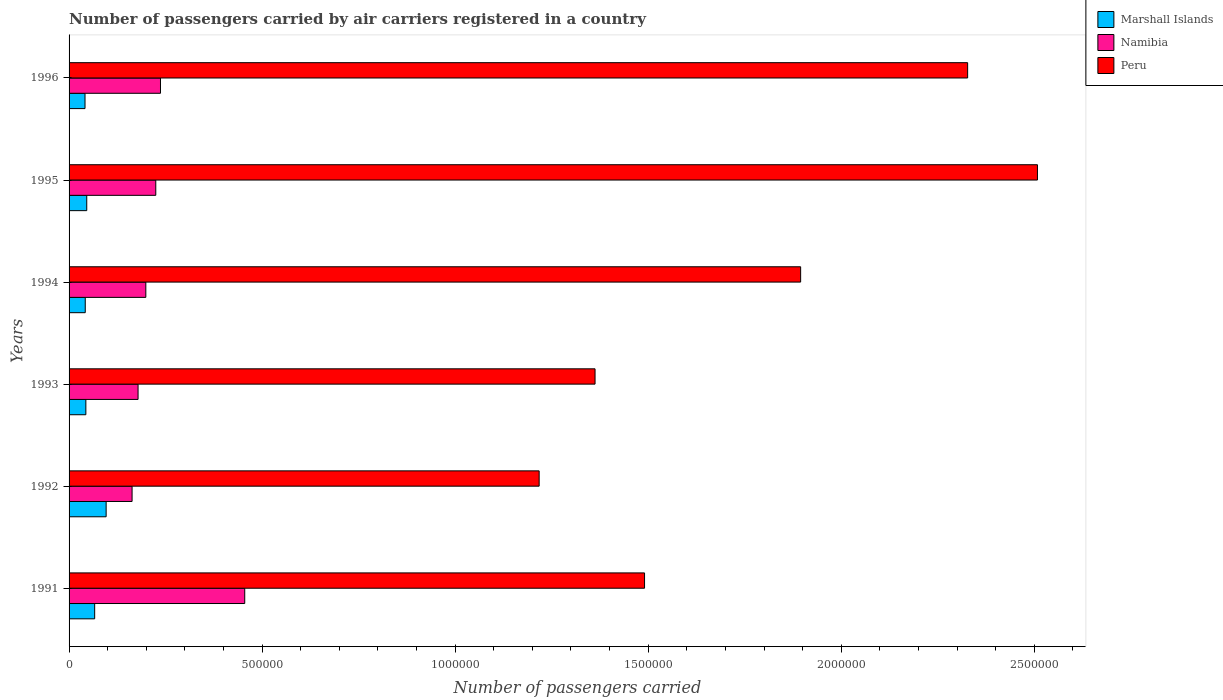How many different coloured bars are there?
Ensure brevity in your answer.  3. How many groups of bars are there?
Your answer should be compact. 6. Are the number of bars per tick equal to the number of legend labels?
Provide a succinct answer. Yes. How many bars are there on the 1st tick from the top?
Make the answer very short. 3. How many bars are there on the 2nd tick from the bottom?
Make the answer very short. 3. What is the label of the 4th group of bars from the top?
Your answer should be very brief. 1993. In how many cases, is the number of bars for a given year not equal to the number of legend labels?
Provide a short and direct response. 0. What is the number of passengers carried by air carriers in Peru in 1995?
Your answer should be compact. 2.51e+06. Across all years, what is the maximum number of passengers carried by air carriers in Marshall Islands?
Make the answer very short. 9.60e+04. Across all years, what is the minimum number of passengers carried by air carriers in Marshall Islands?
Your answer should be very brief. 4.13e+04. In which year was the number of passengers carried by air carriers in Peru maximum?
Provide a succinct answer. 1995. What is the total number of passengers carried by air carriers in Namibia in the graph?
Offer a terse response. 1.46e+06. What is the difference between the number of passengers carried by air carriers in Marshall Islands in 1991 and that in 1996?
Provide a succinct answer. 2.50e+04. What is the difference between the number of passengers carried by air carriers in Marshall Islands in 1993 and the number of passengers carried by air carriers in Namibia in 1996?
Your answer should be compact. -1.93e+05. What is the average number of passengers carried by air carriers in Namibia per year?
Your response must be concise. 2.43e+05. In the year 1991, what is the difference between the number of passengers carried by air carriers in Namibia and number of passengers carried by air carriers in Peru?
Offer a very short reply. -1.04e+06. In how many years, is the number of passengers carried by air carriers in Namibia greater than 2000000 ?
Ensure brevity in your answer.  0. What is the ratio of the number of passengers carried by air carriers in Peru in 1992 to that in 1995?
Provide a short and direct response. 0.49. Is the number of passengers carried by air carriers in Marshall Islands in 1992 less than that in 1996?
Offer a terse response. No. What is the difference between the highest and the second highest number of passengers carried by air carriers in Peru?
Your response must be concise. 1.81e+05. What is the difference between the highest and the lowest number of passengers carried by air carriers in Marshall Islands?
Offer a terse response. 5.47e+04. Is the sum of the number of passengers carried by air carriers in Marshall Islands in 1992 and 1996 greater than the maximum number of passengers carried by air carriers in Namibia across all years?
Give a very brief answer. No. What does the 2nd bar from the top in 1992 represents?
Keep it short and to the point. Namibia. What does the 1st bar from the bottom in 1996 represents?
Offer a very short reply. Marshall Islands. What is the difference between two consecutive major ticks on the X-axis?
Keep it short and to the point. 5.00e+05. Does the graph contain any zero values?
Make the answer very short. No. How many legend labels are there?
Give a very brief answer. 3. How are the legend labels stacked?
Offer a terse response. Vertical. What is the title of the graph?
Your answer should be very brief. Number of passengers carried by air carriers registered in a country. Does "United Arab Emirates" appear as one of the legend labels in the graph?
Give a very brief answer. No. What is the label or title of the X-axis?
Ensure brevity in your answer.  Number of passengers carried. What is the Number of passengers carried of Marshall Islands in 1991?
Your response must be concise. 6.63e+04. What is the Number of passengers carried of Namibia in 1991?
Your answer should be very brief. 4.55e+05. What is the Number of passengers carried in Peru in 1991?
Offer a very short reply. 1.49e+06. What is the Number of passengers carried of Marshall Islands in 1992?
Your answer should be very brief. 9.60e+04. What is the Number of passengers carried of Namibia in 1992?
Your response must be concise. 1.63e+05. What is the Number of passengers carried of Peru in 1992?
Keep it short and to the point. 1.22e+06. What is the Number of passengers carried of Marshall Islands in 1993?
Your response must be concise. 4.35e+04. What is the Number of passengers carried in Namibia in 1993?
Ensure brevity in your answer.  1.79e+05. What is the Number of passengers carried in Peru in 1993?
Your answer should be compact. 1.36e+06. What is the Number of passengers carried of Marshall Islands in 1994?
Provide a succinct answer. 4.19e+04. What is the Number of passengers carried of Namibia in 1994?
Provide a short and direct response. 1.99e+05. What is the Number of passengers carried of Peru in 1994?
Your answer should be very brief. 1.89e+06. What is the Number of passengers carried of Marshall Islands in 1995?
Your response must be concise. 4.58e+04. What is the Number of passengers carried in Namibia in 1995?
Keep it short and to the point. 2.25e+05. What is the Number of passengers carried of Peru in 1995?
Offer a terse response. 2.51e+06. What is the Number of passengers carried of Marshall Islands in 1996?
Make the answer very short. 4.13e+04. What is the Number of passengers carried of Namibia in 1996?
Offer a terse response. 2.37e+05. What is the Number of passengers carried in Peru in 1996?
Your response must be concise. 2.33e+06. Across all years, what is the maximum Number of passengers carried in Marshall Islands?
Offer a very short reply. 9.60e+04. Across all years, what is the maximum Number of passengers carried of Namibia?
Your answer should be compact. 4.55e+05. Across all years, what is the maximum Number of passengers carried in Peru?
Your answer should be very brief. 2.51e+06. Across all years, what is the minimum Number of passengers carried of Marshall Islands?
Make the answer very short. 4.13e+04. Across all years, what is the minimum Number of passengers carried in Namibia?
Offer a terse response. 1.63e+05. Across all years, what is the minimum Number of passengers carried of Peru?
Make the answer very short. 1.22e+06. What is the total Number of passengers carried in Marshall Islands in the graph?
Your answer should be compact. 3.35e+05. What is the total Number of passengers carried in Namibia in the graph?
Your answer should be compact. 1.46e+06. What is the total Number of passengers carried in Peru in the graph?
Your response must be concise. 1.08e+07. What is the difference between the Number of passengers carried in Marshall Islands in 1991 and that in 1992?
Make the answer very short. -2.97e+04. What is the difference between the Number of passengers carried of Namibia in 1991 and that in 1992?
Provide a succinct answer. 2.92e+05. What is the difference between the Number of passengers carried of Peru in 1991 and that in 1992?
Offer a very short reply. 2.73e+05. What is the difference between the Number of passengers carried in Marshall Islands in 1991 and that in 1993?
Provide a succinct answer. 2.28e+04. What is the difference between the Number of passengers carried in Namibia in 1991 and that in 1993?
Give a very brief answer. 2.76e+05. What is the difference between the Number of passengers carried of Peru in 1991 and that in 1993?
Provide a short and direct response. 1.28e+05. What is the difference between the Number of passengers carried of Marshall Islands in 1991 and that in 1994?
Offer a very short reply. 2.44e+04. What is the difference between the Number of passengers carried in Namibia in 1991 and that in 1994?
Your answer should be very brief. 2.56e+05. What is the difference between the Number of passengers carried in Peru in 1991 and that in 1994?
Provide a succinct answer. -4.04e+05. What is the difference between the Number of passengers carried of Marshall Islands in 1991 and that in 1995?
Provide a short and direct response. 2.05e+04. What is the difference between the Number of passengers carried of Namibia in 1991 and that in 1995?
Keep it short and to the point. 2.30e+05. What is the difference between the Number of passengers carried of Peru in 1991 and that in 1995?
Provide a succinct answer. -1.02e+06. What is the difference between the Number of passengers carried in Marshall Islands in 1991 and that in 1996?
Offer a very short reply. 2.50e+04. What is the difference between the Number of passengers carried of Namibia in 1991 and that in 1996?
Keep it short and to the point. 2.18e+05. What is the difference between the Number of passengers carried of Peru in 1991 and that in 1996?
Make the answer very short. -8.37e+05. What is the difference between the Number of passengers carried in Marshall Islands in 1992 and that in 1993?
Offer a terse response. 5.25e+04. What is the difference between the Number of passengers carried in Namibia in 1992 and that in 1993?
Offer a very short reply. -1.55e+04. What is the difference between the Number of passengers carried of Peru in 1992 and that in 1993?
Make the answer very short. -1.45e+05. What is the difference between the Number of passengers carried in Marshall Islands in 1992 and that in 1994?
Your answer should be very brief. 5.41e+04. What is the difference between the Number of passengers carried of Namibia in 1992 and that in 1994?
Keep it short and to the point. -3.56e+04. What is the difference between the Number of passengers carried in Peru in 1992 and that in 1994?
Offer a very short reply. -6.77e+05. What is the difference between the Number of passengers carried of Marshall Islands in 1992 and that in 1995?
Provide a short and direct response. 5.02e+04. What is the difference between the Number of passengers carried of Namibia in 1992 and that in 1995?
Keep it short and to the point. -6.14e+04. What is the difference between the Number of passengers carried of Peru in 1992 and that in 1995?
Offer a very short reply. -1.29e+06. What is the difference between the Number of passengers carried of Marshall Islands in 1992 and that in 1996?
Ensure brevity in your answer.  5.47e+04. What is the difference between the Number of passengers carried in Namibia in 1992 and that in 1996?
Give a very brief answer. -7.36e+04. What is the difference between the Number of passengers carried in Peru in 1992 and that in 1996?
Provide a succinct answer. -1.11e+06. What is the difference between the Number of passengers carried in Marshall Islands in 1993 and that in 1994?
Provide a succinct answer. 1600. What is the difference between the Number of passengers carried of Namibia in 1993 and that in 1994?
Provide a succinct answer. -2.01e+04. What is the difference between the Number of passengers carried of Peru in 1993 and that in 1994?
Your answer should be compact. -5.32e+05. What is the difference between the Number of passengers carried of Marshall Islands in 1993 and that in 1995?
Your answer should be very brief. -2300. What is the difference between the Number of passengers carried of Namibia in 1993 and that in 1995?
Provide a short and direct response. -4.59e+04. What is the difference between the Number of passengers carried in Peru in 1993 and that in 1995?
Your response must be concise. -1.15e+06. What is the difference between the Number of passengers carried of Marshall Islands in 1993 and that in 1996?
Keep it short and to the point. 2200. What is the difference between the Number of passengers carried of Namibia in 1993 and that in 1996?
Your answer should be compact. -5.81e+04. What is the difference between the Number of passengers carried in Peru in 1993 and that in 1996?
Give a very brief answer. -9.65e+05. What is the difference between the Number of passengers carried in Marshall Islands in 1994 and that in 1995?
Your answer should be very brief. -3900. What is the difference between the Number of passengers carried of Namibia in 1994 and that in 1995?
Ensure brevity in your answer.  -2.58e+04. What is the difference between the Number of passengers carried in Peru in 1994 and that in 1995?
Your answer should be compact. -6.13e+05. What is the difference between the Number of passengers carried of Marshall Islands in 1994 and that in 1996?
Provide a short and direct response. 600. What is the difference between the Number of passengers carried in Namibia in 1994 and that in 1996?
Keep it short and to the point. -3.80e+04. What is the difference between the Number of passengers carried of Peru in 1994 and that in 1996?
Your answer should be compact. -4.33e+05. What is the difference between the Number of passengers carried in Marshall Islands in 1995 and that in 1996?
Keep it short and to the point. 4500. What is the difference between the Number of passengers carried of Namibia in 1995 and that in 1996?
Your answer should be compact. -1.22e+04. What is the difference between the Number of passengers carried of Peru in 1995 and that in 1996?
Offer a terse response. 1.81e+05. What is the difference between the Number of passengers carried in Marshall Islands in 1991 and the Number of passengers carried in Namibia in 1992?
Provide a succinct answer. -9.69e+04. What is the difference between the Number of passengers carried in Marshall Islands in 1991 and the Number of passengers carried in Peru in 1992?
Offer a very short reply. -1.15e+06. What is the difference between the Number of passengers carried in Namibia in 1991 and the Number of passengers carried in Peru in 1992?
Your answer should be compact. -7.63e+05. What is the difference between the Number of passengers carried of Marshall Islands in 1991 and the Number of passengers carried of Namibia in 1993?
Provide a succinct answer. -1.12e+05. What is the difference between the Number of passengers carried in Marshall Islands in 1991 and the Number of passengers carried in Peru in 1993?
Ensure brevity in your answer.  -1.30e+06. What is the difference between the Number of passengers carried of Namibia in 1991 and the Number of passengers carried of Peru in 1993?
Your response must be concise. -9.07e+05. What is the difference between the Number of passengers carried in Marshall Islands in 1991 and the Number of passengers carried in Namibia in 1994?
Ensure brevity in your answer.  -1.32e+05. What is the difference between the Number of passengers carried of Marshall Islands in 1991 and the Number of passengers carried of Peru in 1994?
Keep it short and to the point. -1.83e+06. What is the difference between the Number of passengers carried in Namibia in 1991 and the Number of passengers carried in Peru in 1994?
Your response must be concise. -1.44e+06. What is the difference between the Number of passengers carried in Marshall Islands in 1991 and the Number of passengers carried in Namibia in 1995?
Offer a very short reply. -1.58e+05. What is the difference between the Number of passengers carried of Marshall Islands in 1991 and the Number of passengers carried of Peru in 1995?
Give a very brief answer. -2.44e+06. What is the difference between the Number of passengers carried of Namibia in 1991 and the Number of passengers carried of Peru in 1995?
Offer a terse response. -2.05e+06. What is the difference between the Number of passengers carried of Marshall Islands in 1991 and the Number of passengers carried of Namibia in 1996?
Offer a very short reply. -1.70e+05. What is the difference between the Number of passengers carried of Marshall Islands in 1991 and the Number of passengers carried of Peru in 1996?
Your answer should be very brief. -2.26e+06. What is the difference between the Number of passengers carried of Namibia in 1991 and the Number of passengers carried of Peru in 1996?
Make the answer very short. -1.87e+06. What is the difference between the Number of passengers carried in Marshall Islands in 1992 and the Number of passengers carried in Namibia in 1993?
Ensure brevity in your answer.  -8.27e+04. What is the difference between the Number of passengers carried of Marshall Islands in 1992 and the Number of passengers carried of Peru in 1993?
Give a very brief answer. -1.27e+06. What is the difference between the Number of passengers carried in Namibia in 1992 and the Number of passengers carried in Peru in 1993?
Offer a very short reply. -1.20e+06. What is the difference between the Number of passengers carried of Marshall Islands in 1992 and the Number of passengers carried of Namibia in 1994?
Keep it short and to the point. -1.03e+05. What is the difference between the Number of passengers carried in Marshall Islands in 1992 and the Number of passengers carried in Peru in 1994?
Make the answer very short. -1.80e+06. What is the difference between the Number of passengers carried of Namibia in 1992 and the Number of passengers carried of Peru in 1994?
Offer a very short reply. -1.73e+06. What is the difference between the Number of passengers carried of Marshall Islands in 1992 and the Number of passengers carried of Namibia in 1995?
Your answer should be very brief. -1.29e+05. What is the difference between the Number of passengers carried of Marshall Islands in 1992 and the Number of passengers carried of Peru in 1995?
Make the answer very short. -2.41e+06. What is the difference between the Number of passengers carried in Namibia in 1992 and the Number of passengers carried in Peru in 1995?
Keep it short and to the point. -2.35e+06. What is the difference between the Number of passengers carried of Marshall Islands in 1992 and the Number of passengers carried of Namibia in 1996?
Ensure brevity in your answer.  -1.41e+05. What is the difference between the Number of passengers carried in Marshall Islands in 1992 and the Number of passengers carried in Peru in 1996?
Make the answer very short. -2.23e+06. What is the difference between the Number of passengers carried in Namibia in 1992 and the Number of passengers carried in Peru in 1996?
Ensure brevity in your answer.  -2.16e+06. What is the difference between the Number of passengers carried in Marshall Islands in 1993 and the Number of passengers carried in Namibia in 1994?
Make the answer very short. -1.55e+05. What is the difference between the Number of passengers carried of Marshall Islands in 1993 and the Number of passengers carried of Peru in 1994?
Your answer should be very brief. -1.85e+06. What is the difference between the Number of passengers carried of Namibia in 1993 and the Number of passengers carried of Peru in 1994?
Provide a succinct answer. -1.72e+06. What is the difference between the Number of passengers carried in Marshall Islands in 1993 and the Number of passengers carried in Namibia in 1995?
Provide a succinct answer. -1.81e+05. What is the difference between the Number of passengers carried of Marshall Islands in 1993 and the Number of passengers carried of Peru in 1995?
Your response must be concise. -2.46e+06. What is the difference between the Number of passengers carried of Namibia in 1993 and the Number of passengers carried of Peru in 1995?
Offer a very short reply. -2.33e+06. What is the difference between the Number of passengers carried in Marshall Islands in 1993 and the Number of passengers carried in Namibia in 1996?
Your answer should be very brief. -1.93e+05. What is the difference between the Number of passengers carried in Marshall Islands in 1993 and the Number of passengers carried in Peru in 1996?
Ensure brevity in your answer.  -2.28e+06. What is the difference between the Number of passengers carried of Namibia in 1993 and the Number of passengers carried of Peru in 1996?
Your answer should be compact. -2.15e+06. What is the difference between the Number of passengers carried of Marshall Islands in 1994 and the Number of passengers carried of Namibia in 1995?
Your answer should be compact. -1.83e+05. What is the difference between the Number of passengers carried in Marshall Islands in 1994 and the Number of passengers carried in Peru in 1995?
Provide a short and direct response. -2.47e+06. What is the difference between the Number of passengers carried of Namibia in 1994 and the Number of passengers carried of Peru in 1995?
Offer a terse response. -2.31e+06. What is the difference between the Number of passengers carried of Marshall Islands in 1994 and the Number of passengers carried of Namibia in 1996?
Offer a very short reply. -1.95e+05. What is the difference between the Number of passengers carried in Marshall Islands in 1994 and the Number of passengers carried in Peru in 1996?
Your answer should be compact. -2.29e+06. What is the difference between the Number of passengers carried of Namibia in 1994 and the Number of passengers carried of Peru in 1996?
Give a very brief answer. -2.13e+06. What is the difference between the Number of passengers carried of Marshall Islands in 1995 and the Number of passengers carried of Namibia in 1996?
Provide a short and direct response. -1.91e+05. What is the difference between the Number of passengers carried in Marshall Islands in 1995 and the Number of passengers carried in Peru in 1996?
Keep it short and to the point. -2.28e+06. What is the difference between the Number of passengers carried in Namibia in 1995 and the Number of passengers carried in Peru in 1996?
Offer a terse response. -2.10e+06. What is the average Number of passengers carried in Marshall Islands per year?
Provide a succinct answer. 5.58e+04. What is the average Number of passengers carried of Namibia per year?
Provide a short and direct response. 2.43e+05. What is the average Number of passengers carried of Peru per year?
Your response must be concise. 1.80e+06. In the year 1991, what is the difference between the Number of passengers carried of Marshall Islands and Number of passengers carried of Namibia?
Offer a very short reply. -3.89e+05. In the year 1991, what is the difference between the Number of passengers carried in Marshall Islands and Number of passengers carried in Peru?
Keep it short and to the point. -1.42e+06. In the year 1991, what is the difference between the Number of passengers carried in Namibia and Number of passengers carried in Peru?
Your answer should be very brief. -1.04e+06. In the year 1992, what is the difference between the Number of passengers carried in Marshall Islands and Number of passengers carried in Namibia?
Provide a succinct answer. -6.72e+04. In the year 1992, what is the difference between the Number of passengers carried of Marshall Islands and Number of passengers carried of Peru?
Your answer should be compact. -1.12e+06. In the year 1992, what is the difference between the Number of passengers carried in Namibia and Number of passengers carried in Peru?
Your answer should be very brief. -1.05e+06. In the year 1993, what is the difference between the Number of passengers carried of Marshall Islands and Number of passengers carried of Namibia?
Provide a succinct answer. -1.35e+05. In the year 1993, what is the difference between the Number of passengers carried of Marshall Islands and Number of passengers carried of Peru?
Make the answer very short. -1.32e+06. In the year 1993, what is the difference between the Number of passengers carried in Namibia and Number of passengers carried in Peru?
Offer a terse response. -1.18e+06. In the year 1994, what is the difference between the Number of passengers carried in Marshall Islands and Number of passengers carried in Namibia?
Your answer should be very brief. -1.57e+05. In the year 1994, what is the difference between the Number of passengers carried of Marshall Islands and Number of passengers carried of Peru?
Provide a short and direct response. -1.85e+06. In the year 1994, what is the difference between the Number of passengers carried in Namibia and Number of passengers carried in Peru?
Your answer should be compact. -1.70e+06. In the year 1995, what is the difference between the Number of passengers carried in Marshall Islands and Number of passengers carried in Namibia?
Provide a succinct answer. -1.79e+05. In the year 1995, what is the difference between the Number of passengers carried in Marshall Islands and Number of passengers carried in Peru?
Provide a succinct answer. -2.46e+06. In the year 1995, what is the difference between the Number of passengers carried of Namibia and Number of passengers carried of Peru?
Offer a terse response. -2.28e+06. In the year 1996, what is the difference between the Number of passengers carried in Marshall Islands and Number of passengers carried in Namibia?
Offer a terse response. -1.96e+05. In the year 1996, what is the difference between the Number of passengers carried of Marshall Islands and Number of passengers carried of Peru?
Provide a succinct answer. -2.29e+06. In the year 1996, what is the difference between the Number of passengers carried of Namibia and Number of passengers carried of Peru?
Ensure brevity in your answer.  -2.09e+06. What is the ratio of the Number of passengers carried in Marshall Islands in 1991 to that in 1992?
Your response must be concise. 0.69. What is the ratio of the Number of passengers carried of Namibia in 1991 to that in 1992?
Offer a very short reply. 2.79. What is the ratio of the Number of passengers carried in Peru in 1991 to that in 1992?
Your answer should be very brief. 1.22. What is the ratio of the Number of passengers carried in Marshall Islands in 1991 to that in 1993?
Offer a very short reply. 1.52. What is the ratio of the Number of passengers carried of Namibia in 1991 to that in 1993?
Provide a short and direct response. 2.55. What is the ratio of the Number of passengers carried in Peru in 1991 to that in 1993?
Your answer should be very brief. 1.09. What is the ratio of the Number of passengers carried of Marshall Islands in 1991 to that in 1994?
Provide a succinct answer. 1.58. What is the ratio of the Number of passengers carried of Namibia in 1991 to that in 1994?
Keep it short and to the point. 2.29. What is the ratio of the Number of passengers carried in Peru in 1991 to that in 1994?
Offer a terse response. 0.79. What is the ratio of the Number of passengers carried in Marshall Islands in 1991 to that in 1995?
Provide a succinct answer. 1.45. What is the ratio of the Number of passengers carried of Namibia in 1991 to that in 1995?
Offer a terse response. 2.03. What is the ratio of the Number of passengers carried in Peru in 1991 to that in 1995?
Your response must be concise. 0.59. What is the ratio of the Number of passengers carried of Marshall Islands in 1991 to that in 1996?
Make the answer very short. 1.61. What is the ratio of the Number of passengers carried of Namibia in 1991 to that in 1996?
Give a very brief answer. 1.92. What is the ratio of the Number of passengers carried in Peru in 1991 to that in 1996?
Ensure brevity in your answer.  0.64. What is the ratio of the Number of passengers carried of Marshall Islands in 1992 to that in 1993?
Your response must be concise. 2.21. What is the ratio of the Number of passengers carried of Namibia in 1992 to that in 1993?
Keep it short and to the point. 0.91. What is the ratio of the Number of passengers carried of Peru in 1992 to that in 1993?
Your answer should be very brief. 0.89. What is the ratio of the Number of passengers carried in Marshall Islands in 1992 to that in 1994?
Offer a terse response. 2.29. What is the ratio of the Number of passengers carried of Namibia in 1992 to that in 1994?
Ensure brevity in your answer.  0.82. What is the ratio of the Number of passengers carried of Peru in 1992 to that in 1994?
Offer a terse response. 0.64. What is the ratio of the Number of passengers carried of Marshall Islands in 1992 to that in 1995?
Offer a terse response. 2.1. What is the ratio of the Number of passengers carried of Namibia in 1992 to that in 1995?
Offer a very short reply. 0.73. What is the ratio of the Number of passengers carried of Peru in 1992 to that in 1995?
Offer a terse response. 0.49. What is the ratio of the Number of passengers carried in Marshall Islands in 1992 to that in 1996?
Provide a succinct answer. 2.32. What is the ratio of the Number of passengers carried in Namibia in 1992 to that in 1996?
Your answer should be compact. 0.69. What is the ratio of the Number of passengers carried in Peru in 1992 to that in 1996?
Offer a very short reply. 0.52. What is the ratio of the Number of passengers carried in Marshall Islands in 1993 to that in 1994?
Offer a terse response. 1.04. What is the ratio of the Number of passengers carried of Namibia in 1993 to that in 1994?
Make the answer very short. 0.9. What is the ratio of the Number of passengers carried of Peru in 1993 to that in 1994?
Make the answer very short. 0.72. What is the ratio of the Number of passengers carried in Marshall Islands in 1993 to that in 1995?
Your answer should be very brief. 0.95. What is the ratio of the Number of passengers carried in Namibia in 1993 to that in 1995?
Your answer should be very brief. 0.8. What is the ratio of the Number of passengers carried in Peru in 1993 to that in 1995?
Provide a short and direct response. 0.54. What is the ratio of the Number of passengers carried in Marshall Islands in 1993 to that in 1996?
Offer a terse response. 1.05. What is the ratio of the Number of passengers carried of Namibia in 1993 to that in 1996?
Give a very brief answer. 0.75. What is the ratio of the Number of passengers carried in Peru in 1993 to that in 1996?
Your answer should be compact. 0.59. What is the ratio of the Number of passengers carried in Marshall Islands in 1994 to that in 1995?
Your response must be concise. 0.91. What is the ratio of the Number of passengers carried in Namibia in 1994 to that in 1995?
Make the answer very short. 0.89. What is the ratio of the Number of passengers carried of Peru in 1994 to that in 1995?
Your answer should be compact. 0.76. What is the ratio of the Number of passengers carried of Marshall Islands in 1994 to that in 1996?
Your answer should be compact. 1.01. What is the ratio of the Number of passengers carried in Namibia in 1994 to that in 1996?
Offer a terse response. 0.84. What is the ratio of the Number of passengers carried in Peru in 1994 to that in 1996?
Your answer should be compact. 0.81. What is the ratio of the Number of passengers carried of Marshall Islands in 1995 to that in 1996?
Keep it short and to the point. 1.11. What is the ratio of the Number of passengers carried of Namibia in 1995 to that in 1996?
Offer a terse response. 0.95. What is the ratio of the Number of passengers carried in Peru in 1995 to that in 1996?
Your answer should be very brief. 1.08. What is the difference between the highest and the second highest Number of passengers carried in Marshall Islands?
Give a very brief answer. 2.97e+04. What is the difference between the highest and the second highest Number of passengers carried in Namibia?
Your answer should be compact. 2.18e+05. What is the difference between the highest and the second highest Number of passengers carried in Peru?
Give a very brief answer. 1.81e+05. What is the difference between the highest and the lowest Number of passengers carried of Marshall Islands?
Offer a very short reply. 5.47e+04. What is the difference between the highest and the lowest Number of passengers carried in Namibia?
Give a very brief answer. 2.92e+05. What is the difference between the highest and the lowest Number of passengers carried in Peru?
Your answer should be compact. 1.29e+06. 